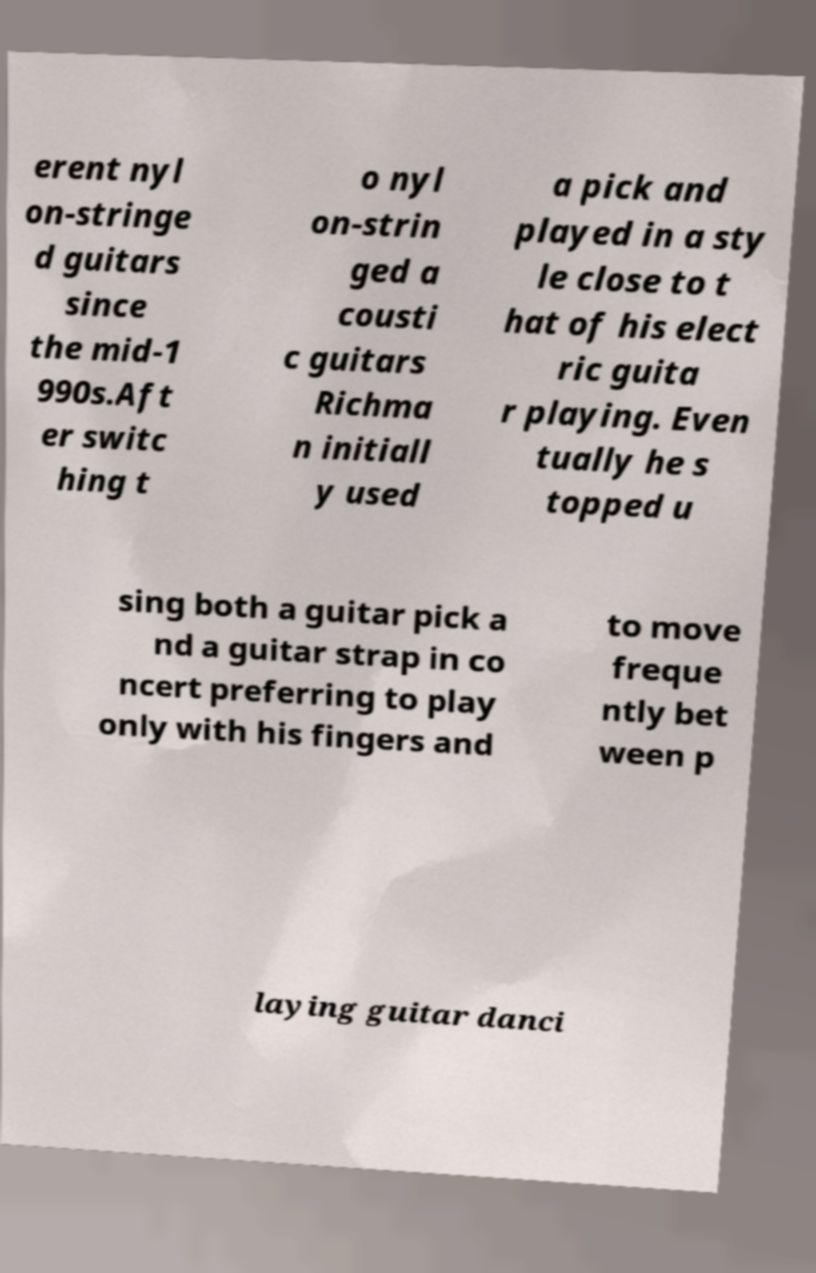I need the written content from this picture converted into text. Can you do that? erent nyl on-stringe d guitars since the mid-1 990s.Aft er switc hing t o nyl on-strin ged a cousti c guitars Richma n initiall y used a pick and played in a sty le close to t hat of his elect ric guita r playing. Even tually he s topped u sing both a guitar pick a nd a guitar strap in co ncert preferring to play only with his fingers and to move freque ntly bet ween p laying guitar danci 